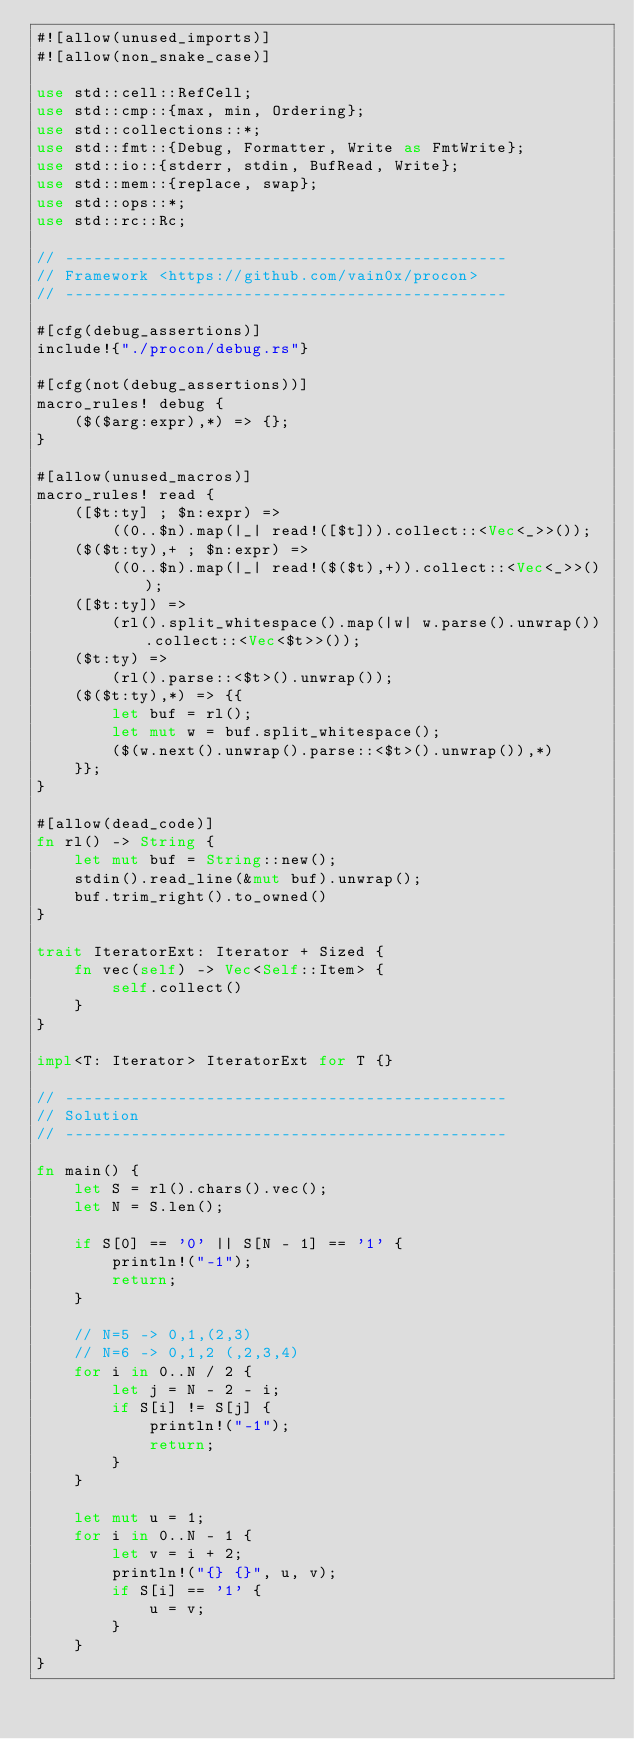<code> <loc_0><loc_0><loc_500><loc_500><_Rust_>#![allow(unused_imports)]
#![allow(non_snake_case)]

use std::cell::RefCell;
use std::cmp::{max, min, Ordering};
use std::collections::*;
use std::fmt::{Debug, Formatter, Write as FmtWrite};
use std::io::{stderr, stdin, BufRead, Write};
use std::mem::{replace, swap};
use std::ops::*;
use std::rc::Rc;

// -----------------------------------------------
// Framework <https://github.com/vain0x/procon>
// -----------------------------------------------

#[cfg(debug_assertions)]
include!{"./procon/debug.rs"}

#[cfg(not(debug_assertions))]
macro_rules! debug {
    ($($arg:expr),*) => {};
}

#[allow(unused_macros)]
macro_rules! read {
    ([$t:ty] ; $n:expr) =>
        ((0..$n).map(|_| read!([$t])).collect::<Vec<_>>());
    ($($t:ty),+ ; $n:expr) =>
        ((0..$n).map(|_| read!($($t),+)).collect::<Vec<_>>());
    ([$t:ty]) =>
        (rl().split_whitespace().map(|w| w.parse().unwrap()).collect::<Vec<$t>>());
    ($t:ty) =>
        (rl().parse::<$t>().unwrap());
    ($($t:ty),*) => {{
        let buf = rl();
        let mut w = buf.split_whitespace();
        ($(w.next().unwrap().parse::<$t>().unwrap()),*)
    }};
}

#[allow(dead_code)]
fn rl() -> String {
    let mut buf = String::new();
    stdin().read_line(&mut buf).unwrap();
    buf.trim_right().to_owned()
}

trait IteratorExt: Iterator + Sized {
    fn vec(self) -> Vec<Self::Item> {
        self.collect()
    }
}

impl<T: Iterator> IteratorExt for T {}

// -----------------------------------------------
// Solution
// -----------------------------------------------

fn main() {
    let S = rl().chars().vec();
    let N = S.len();

    if S[0] == '0' || S[N - 1] == '1' {
        println!("-1");
        return;
    }

    // N=5 -> 0,1,(2,3)
    // N=6 -> 0,1,2 (,2,3,4)
    for i in 0..N / 2 {
        let j = N - 2 - i;
        if S[i] != S[j] {
            println!("-1");
            return;
        }
    }

    let mut u = 1;
    for i in 0..N - 1 {
        let v = i + 2;
        println!("{} {}", u, v);
        if S[i] == '1' {
            u = v;
        }
    }
}
</code> 